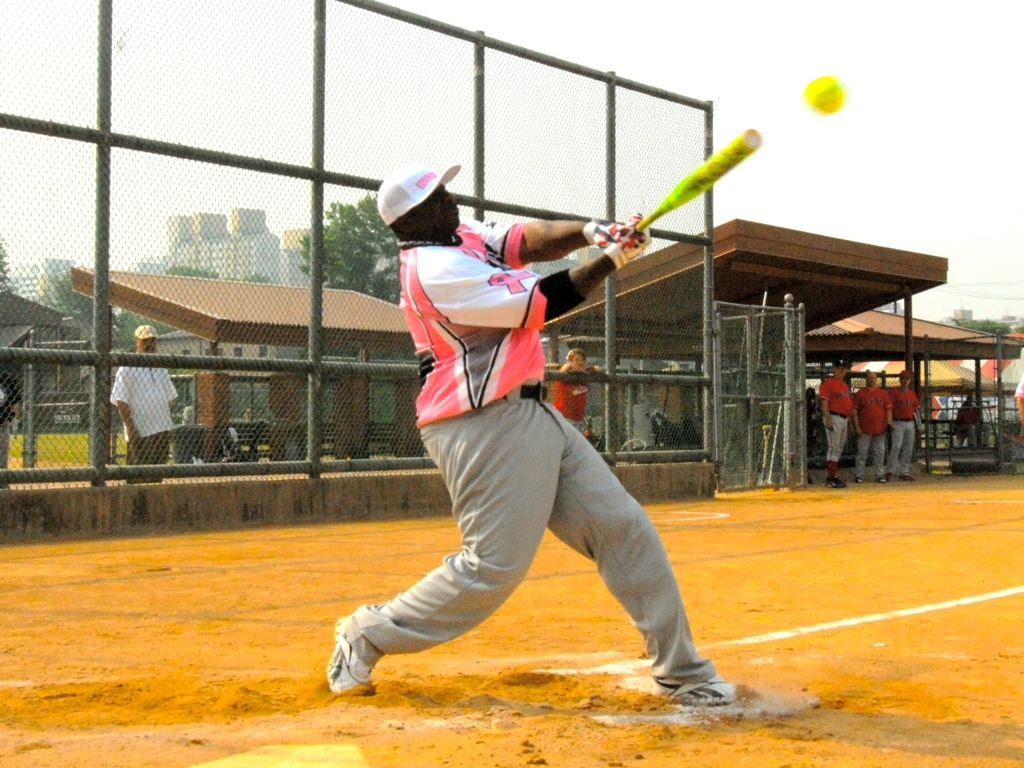What does the player's attire suggest about the team? The player's attire, featuring a striking pink and white jersey, suggests the team has a unique and possibly personalized uniform. This colorful and coordinated outfit could indicate a sense of team spirit and identity. Additionally, the attire includes protective gear like a helmet, indicating adherence to safety standards of the sport. 